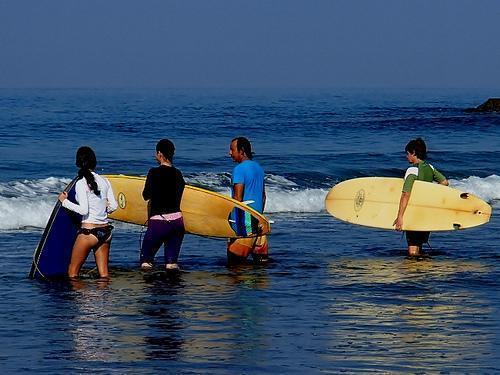How many people are there?
Give a very brief answer. 4. How many women have surfboards?
Give a very brief answer. 2. How many people are in the water?
Give a very brief answer. 4. How many men are there?
Give a very brief answer. 2. How many people are holding surfboards?
Give a very brief answer. 3. How many people are in the photo?
Give a very brief answer. 4. How many people have on bikini bottoms?
Give a very brief answer. 1. 